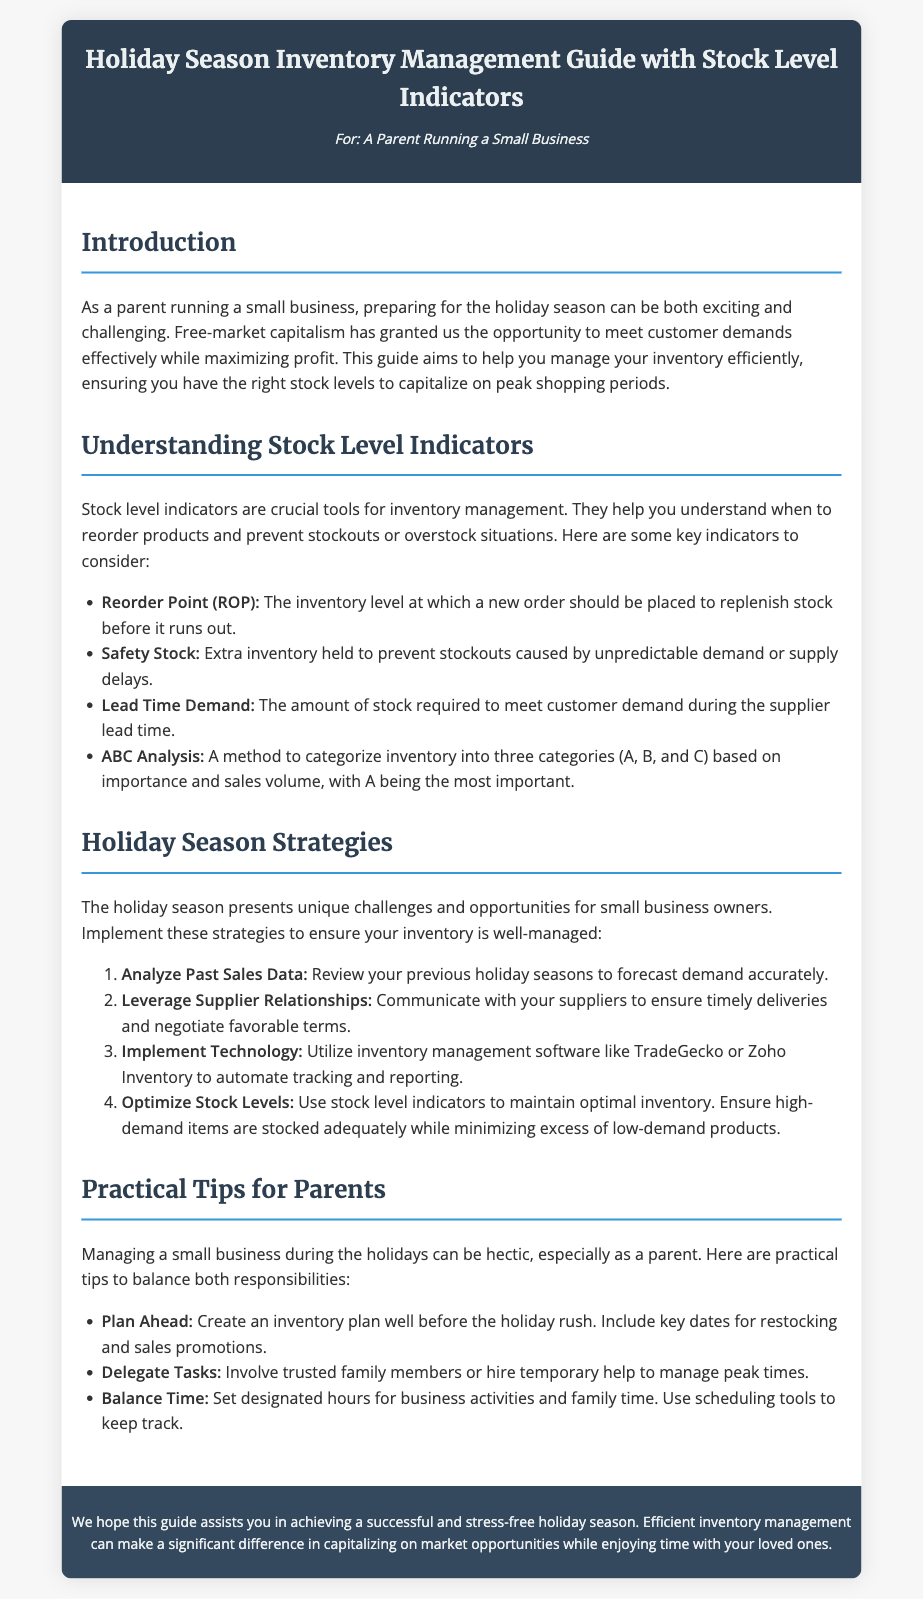What is the title of the guide? The title of the guide is presented in the header section of the document.
Answer: Holiday Season Inventory Management Guide with Stock Level Indicators Who is the intended audience of the guide? The intended audience is specified directly under the title.
Answer: A Parent Running a Small Business What is the first stock level indicator mentioned? The first stock level indicator is listed in the section about understanding stock level indicators.
Answer: Reorder Point (ROP) What is one strategy suggested for the holiday season? A number of strategies are listed under the holiday season strategies section; the question asks for one of them.
Answer: Analyze Past Sales Data How can parents balance business and family time? The document provides practical tips specifically under a designated section.
Answer: Set designated hours for business activities and family time What does ABC Analysis categorize? The specific method mentioned in the guide categorizes inventory.
Answer: Inventory into three categories (A, B, and C) How many practical tips are provided for parents? The tips are outlined in the relevant section; they can be counted.
Answer: Three What should you implement to automate tracking? The guide suggests a specific type of tool to improve inventory management.
Answer: Inventory management software What is the background color of the footer? The footer's color is described in the CSS styling section of the document.
Answer: #34495e 